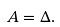<formula> <loc_0><loc_0><loc_500><loc_500>A = \Delta .</formula> 